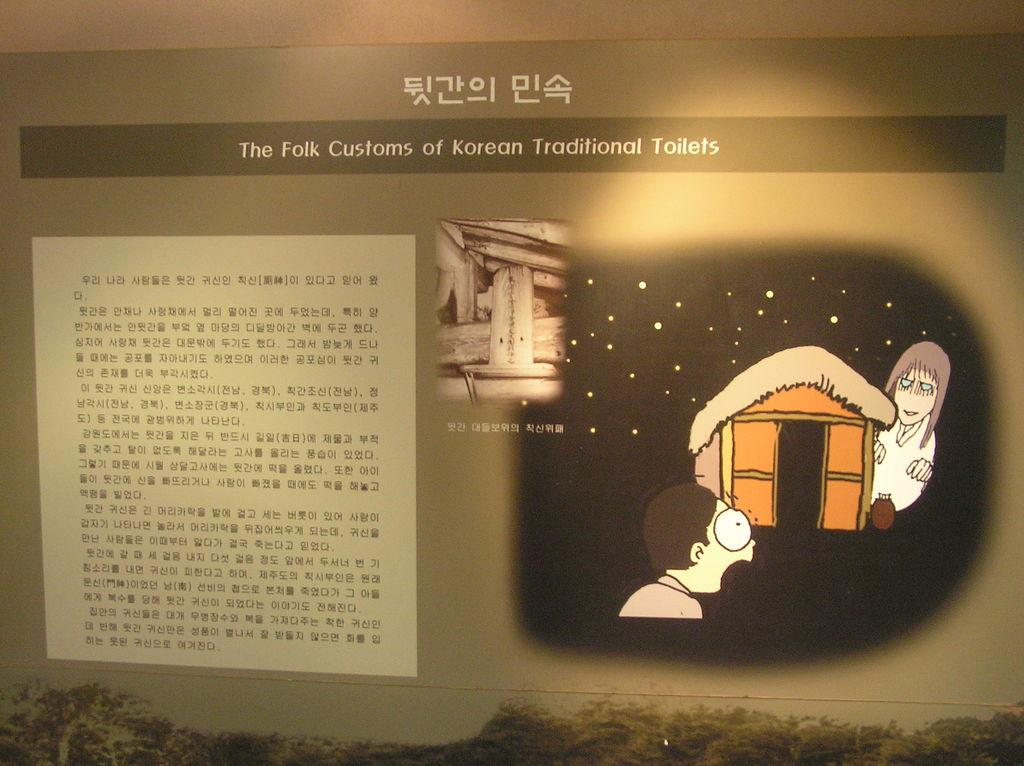What type of visual is the image? The image is a poster. What can be seen on the poster? There is a depiction on the poster. Are there any words on the poster? Yes, there is text on the poster. What flavor of ice cream is being advertised on the poster? There is no mention of ice cream or any specific flavor in the image, as it is a poster with a depiction and text. 